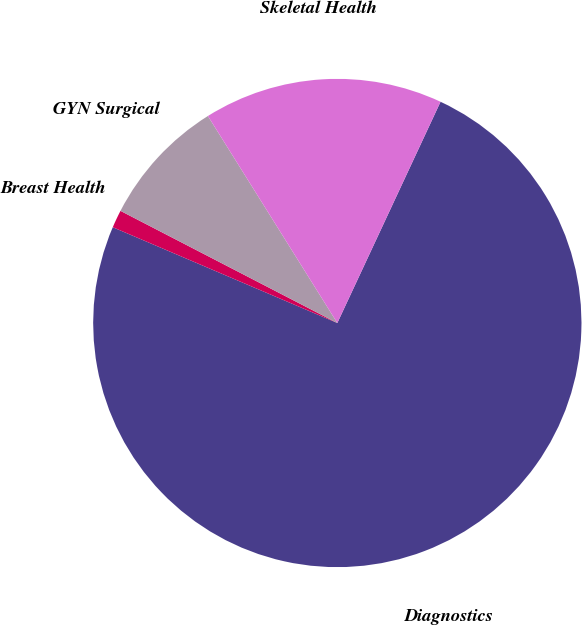Convert chart. <chart><loc_0><loc_0><loc_500><loc_500><pie_chart><fcel>Diagnostics<fcel>Breast Health<fcel>GYN Surgical<fcel>Skeletal Health<nl><fcel>74.47%<fcel>1.18%<fcel>8.51%<fcel>15.84%<nl></chart> 